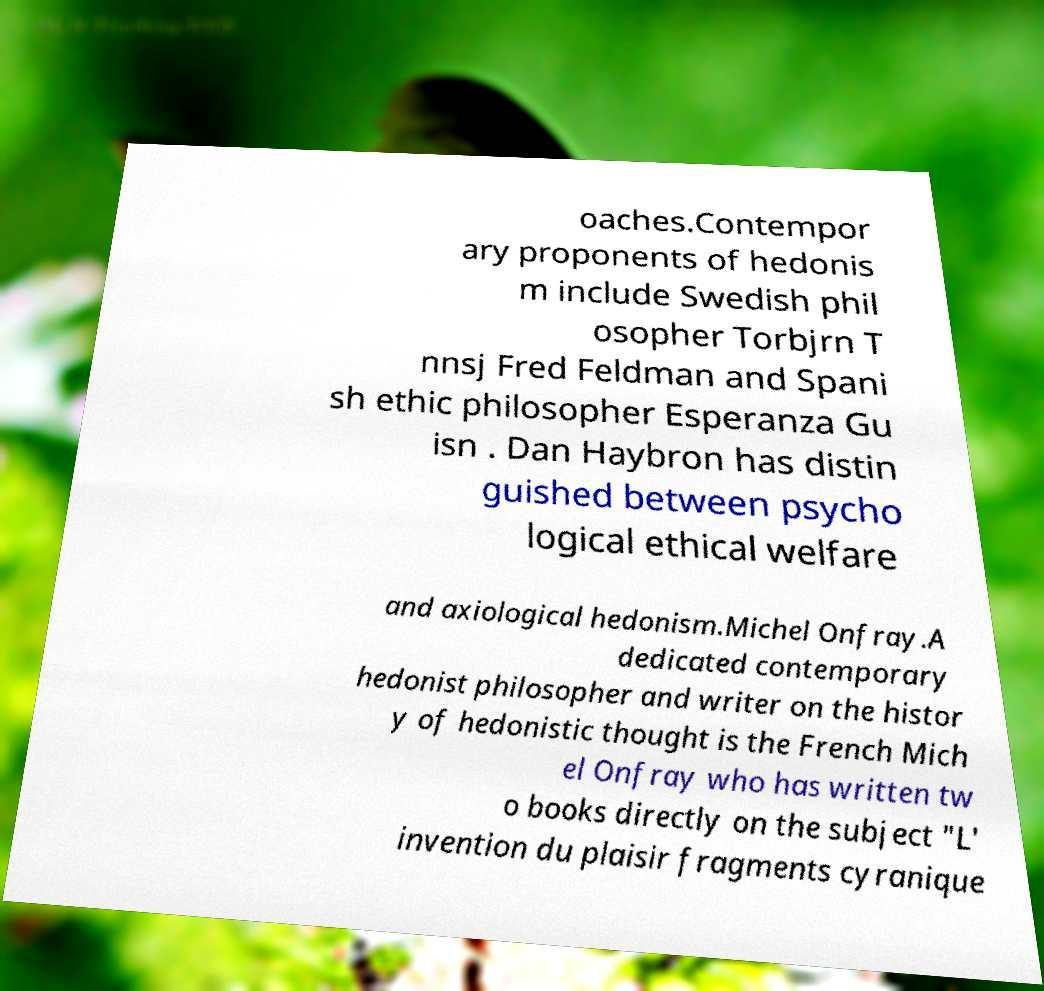Could you extract and type out the text from this image? oaches.Contempor ary proponents of hedonis m include Swedish phil osopher Torbjrn T nnsj Fred Feldman and Spani sh ethic philosopher Esperanza Gu isn . Dan Haybron has distin guished between psycho logical ethical welfare and axiological hedonism.Michel Onfray.A dedicated contemporary hedonist philosopher and writer on the histor y of hedonistic thought is the French Mich el Onfray who has written tw o books directly on the subject "L' invention du plaisir fragments cyranique 